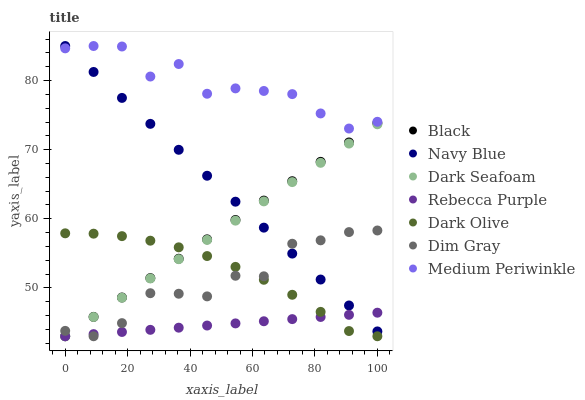Does Rebecca Purple have the minimum area under the curve?
Answer yes or no. Yes. Does Medium Periwinkle have the maximum area under the curve?
Answer yes or no. Yes. Does Navy Blue have the minimum area under the curve?
Answer yes or no. No. Does Navy Blue have the maximum area under the curve?
Answer yes or no. No. Is Rebecca Purple the smoothest?
Answer yes or no. Yes. Is Medium Periwinkle the roughest?
Answer yes or no. Yes. Is Navy Blue the smoothest?
Answer yes or no. No. Is Navy Blue the roughest?
Answer yes or no. No. Does Dim Gray have the lowest value?
Answer yes or no. Yes. Does Navy Blue have the lowest value?
Answer yes or no. No. Does Medium Periwinkle have the highest value?
Answer yes or no. Yes. Does Dark Olive have the highest value?
Answer yes or no. No. Is Black less than Medium Periwinkle?
Answer yes or no. Yes. Is Medium Periwinkle greater than Black?
Answer yes or no. Yes. Does Dark Seafoam intersect Navy Blue?
Answer yes or no. Yes. Is Dark Seafoam less than Navy Blue?
Answer yes or no. No. Is Dark Seafoam greater than Navy Blue?
Answer yes or no. No. Does Black intersect Medium Periwinkle?
Answer yes or no. No. 